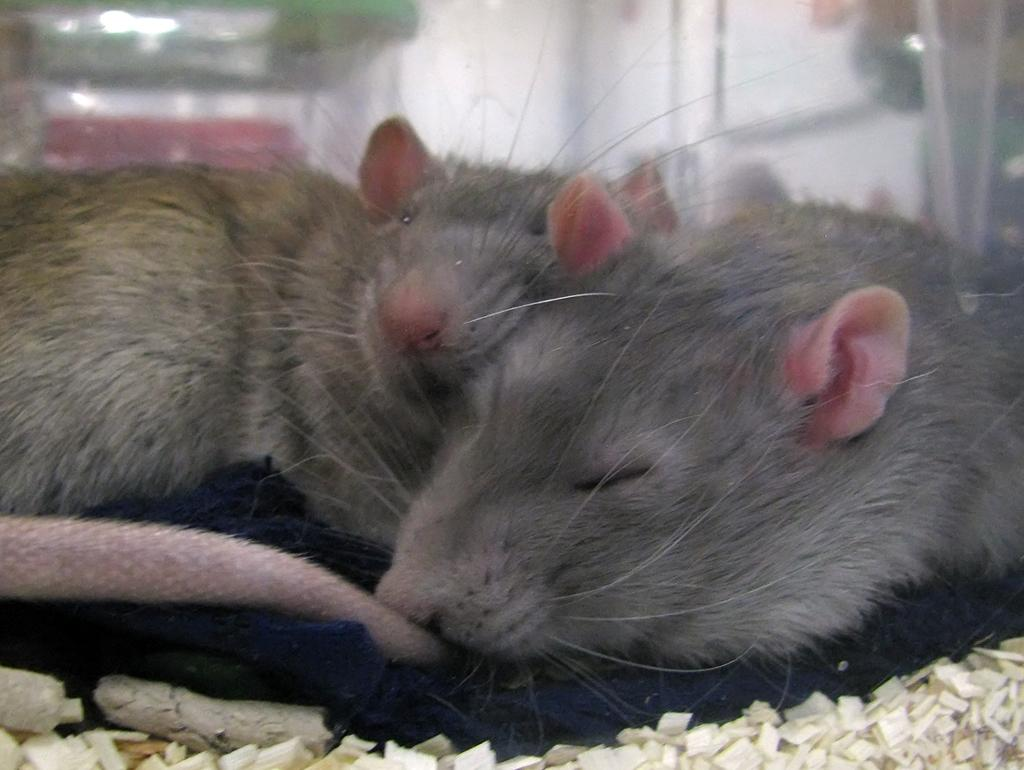How many rats are present in the image? There are two rats in the image. What color are the objects in the image? The objects in the image are white-colored. Can you describe the background of the image? The background of the image is blurred. What type of creature can be seen wearing a ring in the image? There is no creature wearing a ring present in the image. 